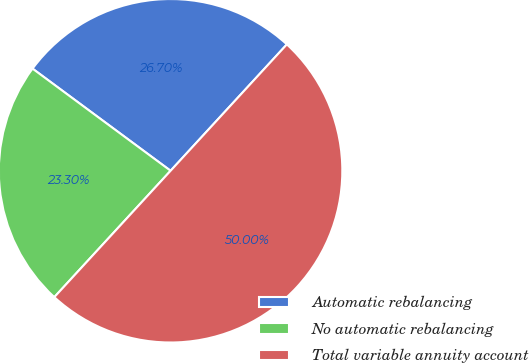Convert chart to OTSL. <chart><loc_0><loc_0><loc_500><loc_500><pie_chart><fcel>Automatic rebalancing<fcel>No automatic rebalancing<fcel>Total variable annuity account<nl><fcel>26.7%<fcel>23.3%<fcel>50.0%<nl></chart> 